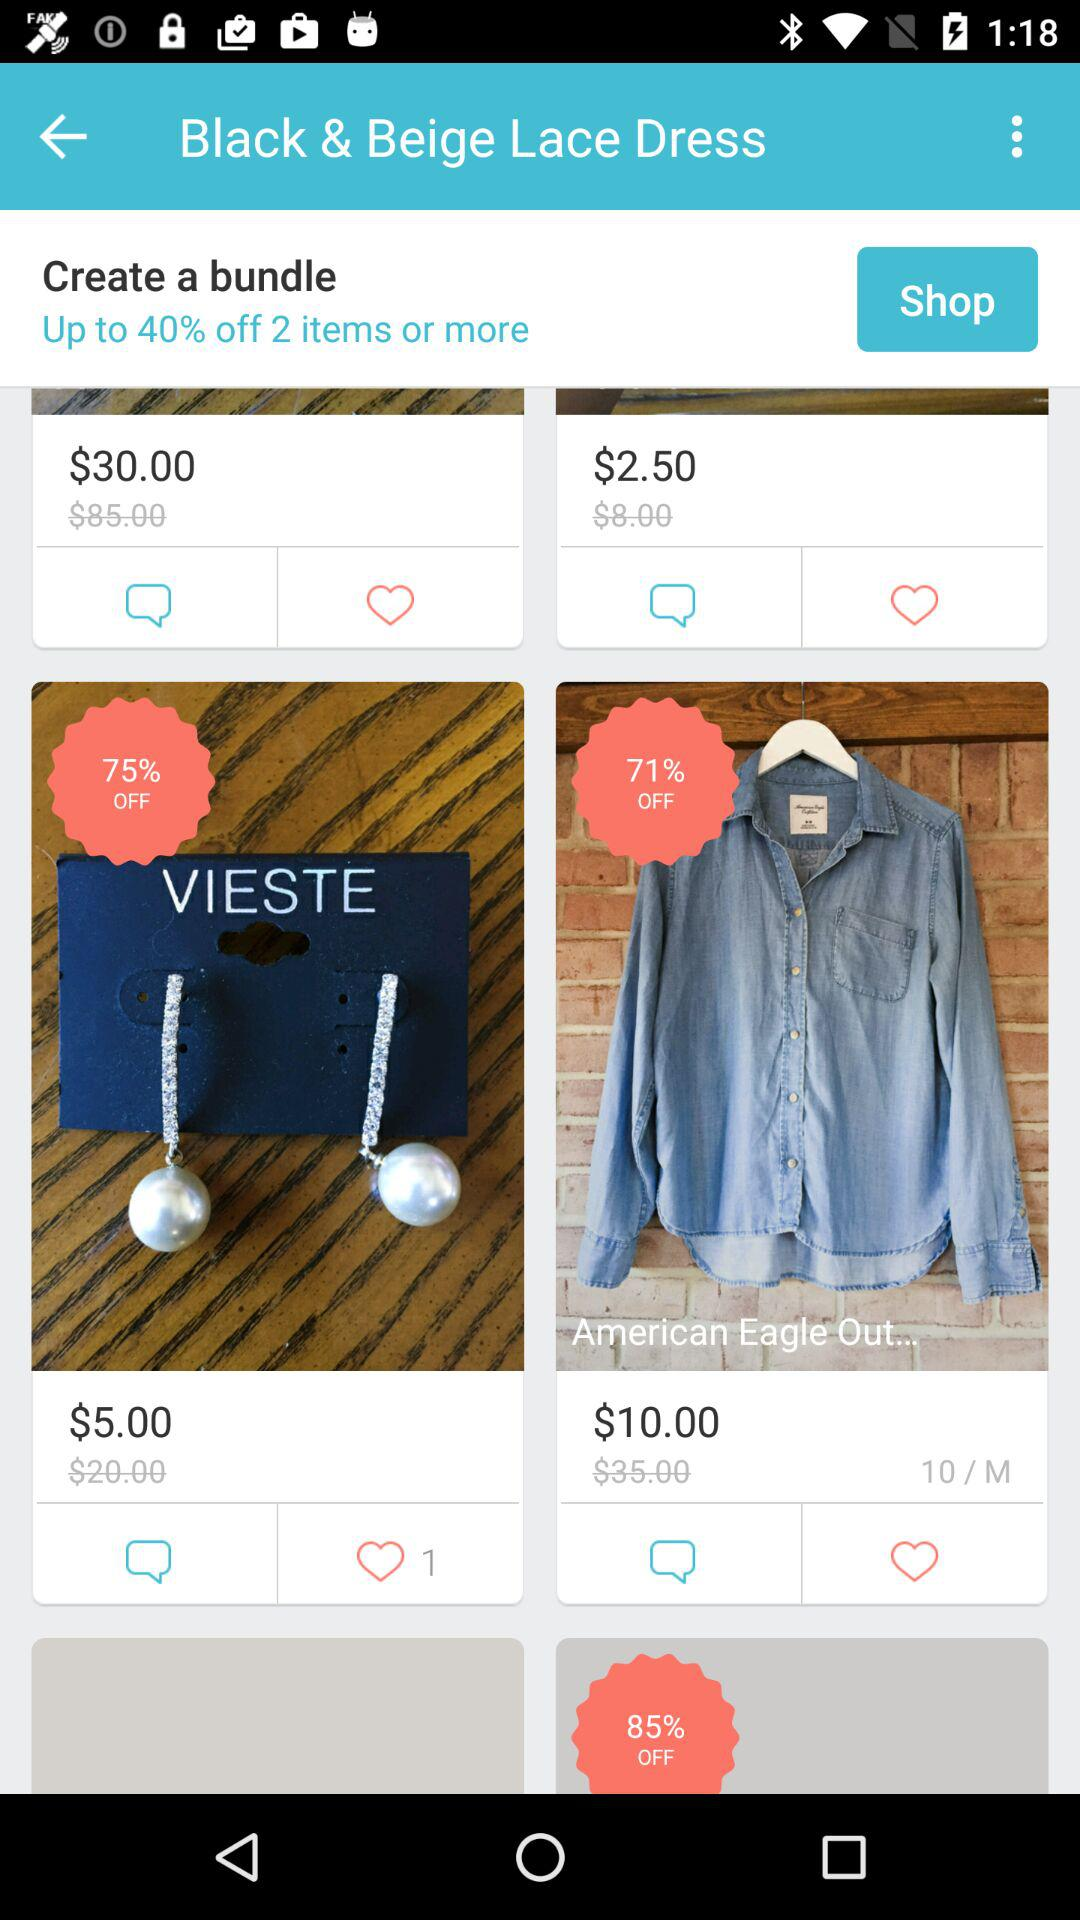What is the cost of "American Eagle Out..." before discount? The cost of "American Eagle Out..." before discount is $35. 